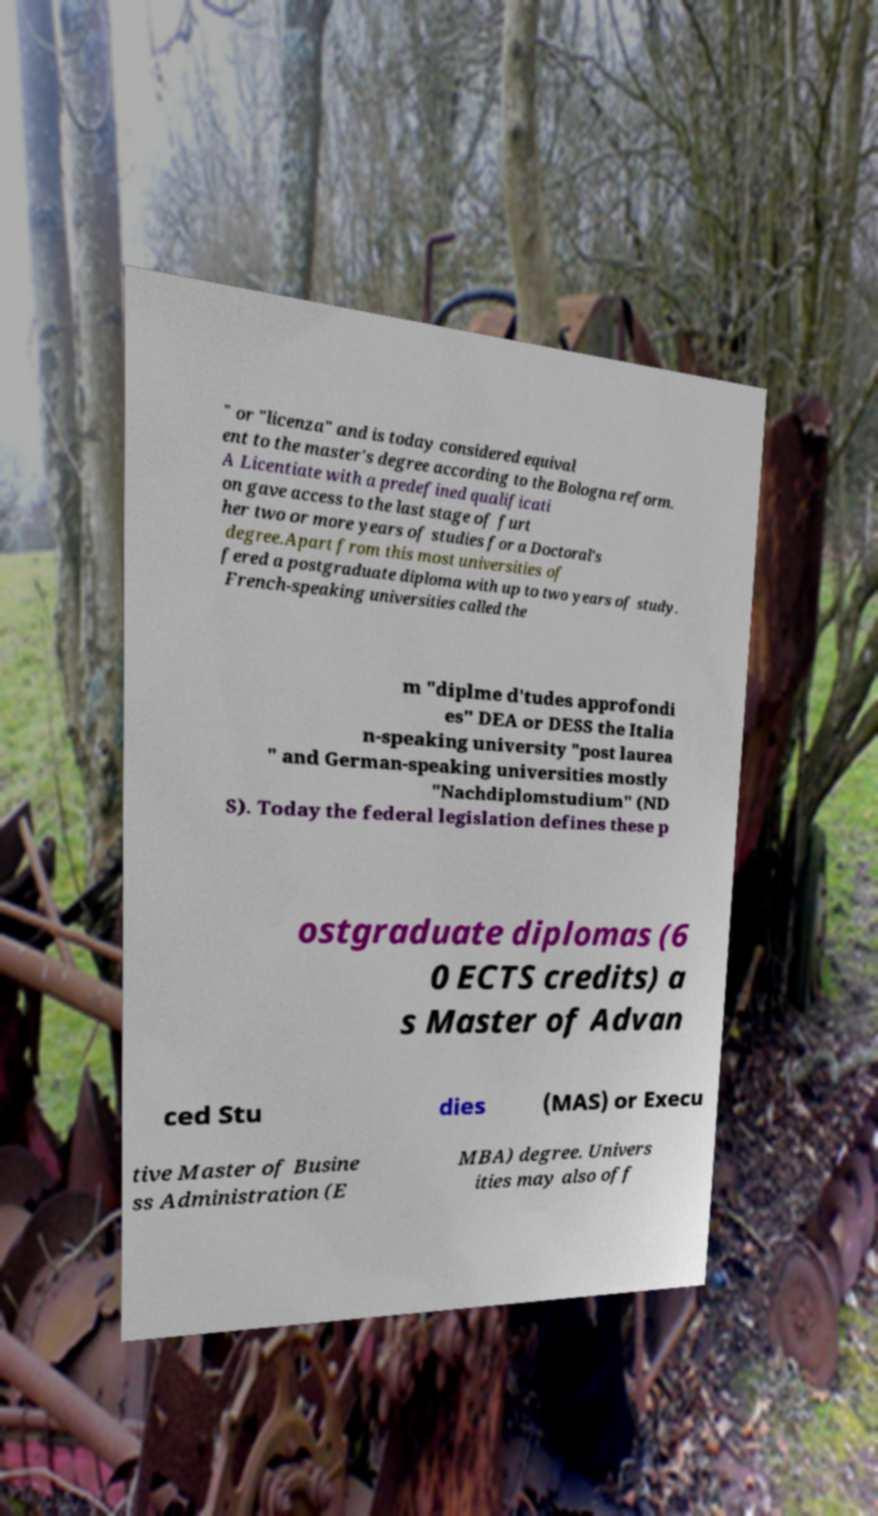Could you extract and type out the text from this image? " or "licenza" and is today considered equival ent to the master's degree according to the Bologna reform. A Licentiate with a predefined qualificati on gave access to the last stage of furt her two or more years of studies for a Doctoral's degree.Apart from this most universities of fered a postgraduate diploma with up to two years of study. French-speaking universities called the m "diplme d'tudes approfondi es" DEA or DESS the Italia n-speaking university "post laurea " and German-speaking universities mostly "Nachdiplomstudium" (ND S). Today the federal legislation defines these p ostgraduate diplomas (6 0 ECTS credits) a s Master of Advan ced Stu dies (MAS) or Execu tive Master of Busine ss Administration (E MBA) degree. Univers ities may also off 